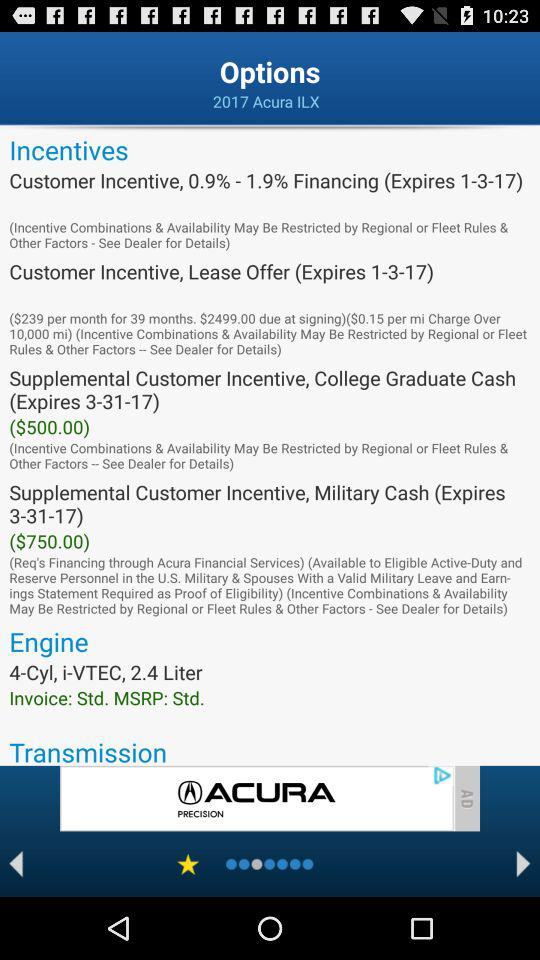What is the model of the vehicle? The model of the vehicle is ILX. 